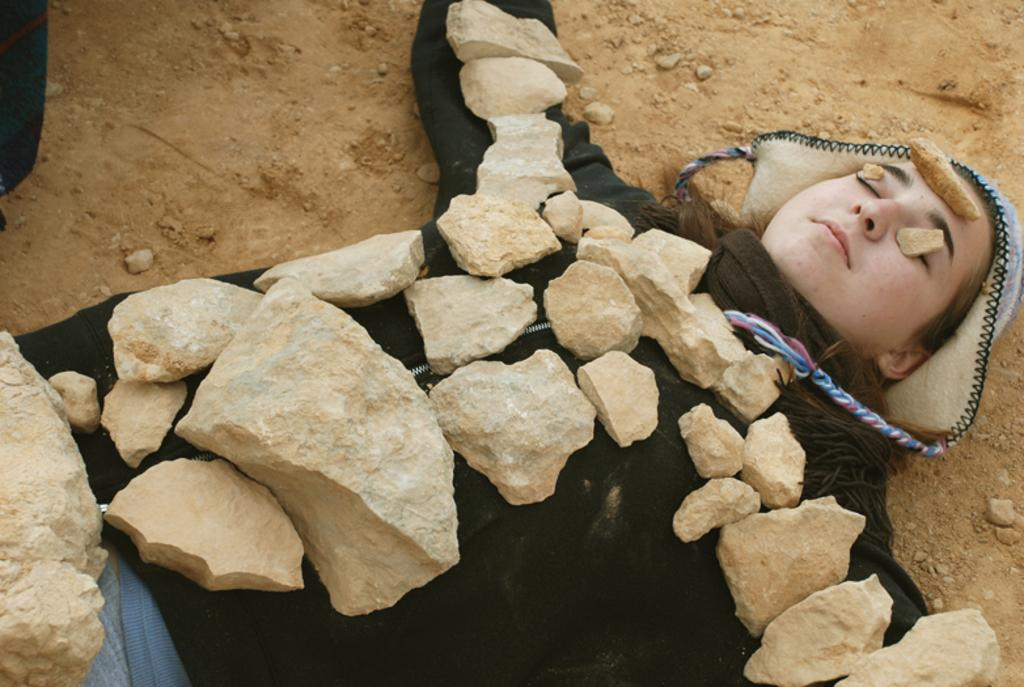Who is the main subject in the image? There is a woman in the image. What is the woman wearing? The woman is wearing a jacket. What is the woman's position in the image? The woman is laying on the ground. What is placed on the woman in the image? There are stones placed on the woman. How many frogs are jumping around the woman in the image? There are no frogs present in the image; it only features a woman laying on the ground with stones placed on her. 